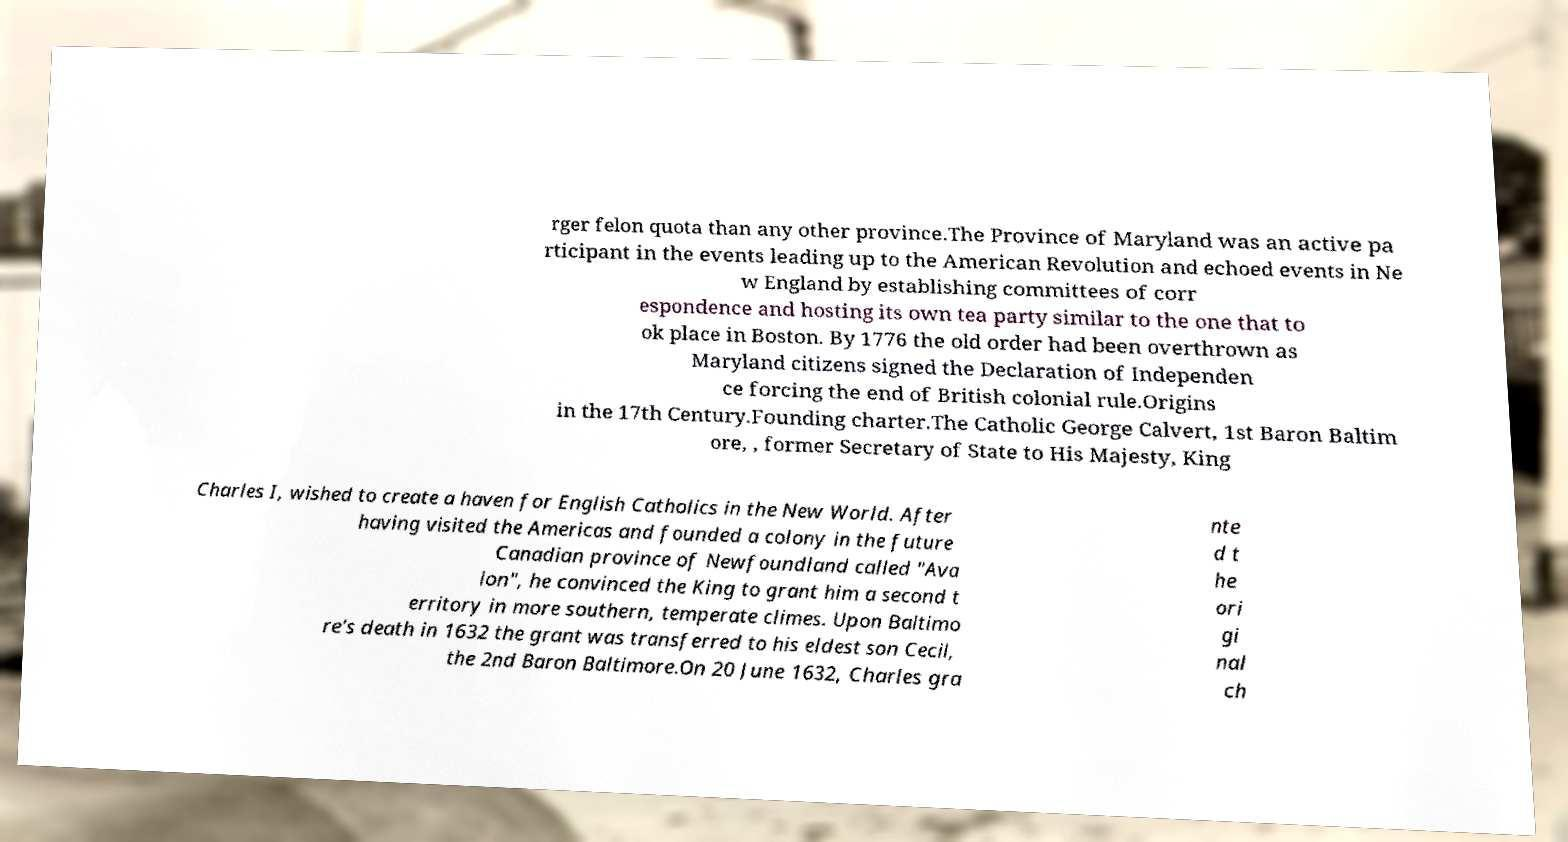Please read and relay the text visible in this image. What does it say? rger felon quota than any other province.The Province of Maryland was an active pa rticipant in the events leading up to the American Revolution and echoed events in Ne w England by establishing committees of corr espondence and hosting its own tea party similar to the one that to ok place in Boston. By 1776 the old order had been overthrown as Maryland citizens signed the Declaration of Independen ce forcing the end of British colonial rule.Origins in the 17th Century.Founding charter.The Catholic George Calvert, 1st Baron Baltim ore, , former Secretary of State to His Majesty, King Charles I, wished to create a haven for English Catholics in the New World. After having visited the Americas and founded a colony in the future Canadian province of Newfoundland called "Ava lon", he convinced the King to grant him a second t erritory in more southern, temperate climes. Upon Baltimo re's death in 1632 the grant was transferred to his eldest son Cecil, the 2nd Baron Baltimore.On 20 June 1632, Charles gra nte d t he ori gi nal ch 